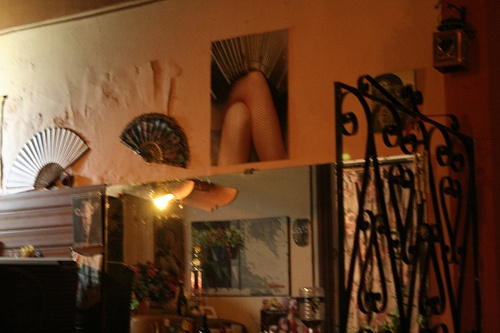Describe the objects in this image and their specific colors. I can see people in olive, maroon, brown, and black tones, chair in olive, black, and gray tones, potted plant in black, maroon, and olive tones, wine glass in olive, black, maroon, and gray tones, and vase in olive, maroon, black, and gray tones in this image. 